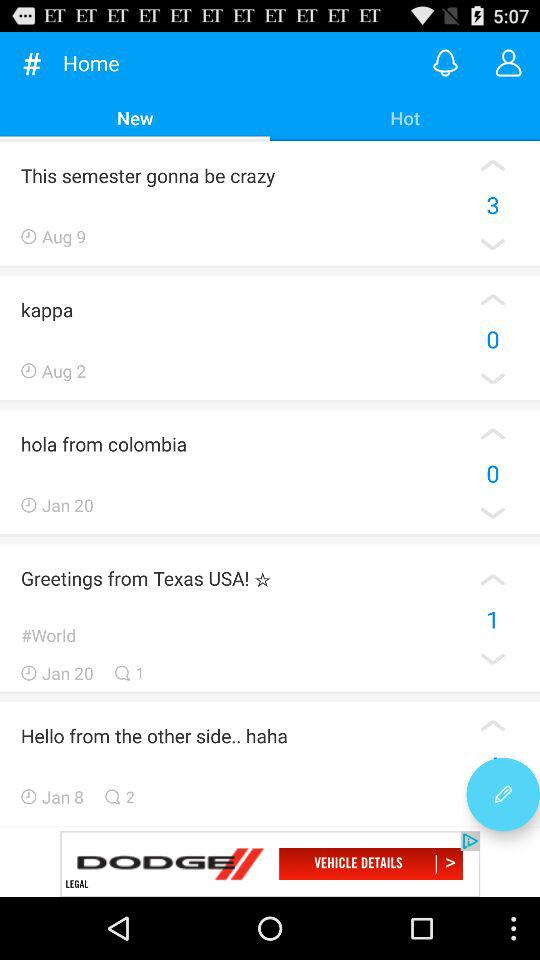When did the "Greetings from Texas USA" come? "Greetings from Texas USA" come on January 20. 